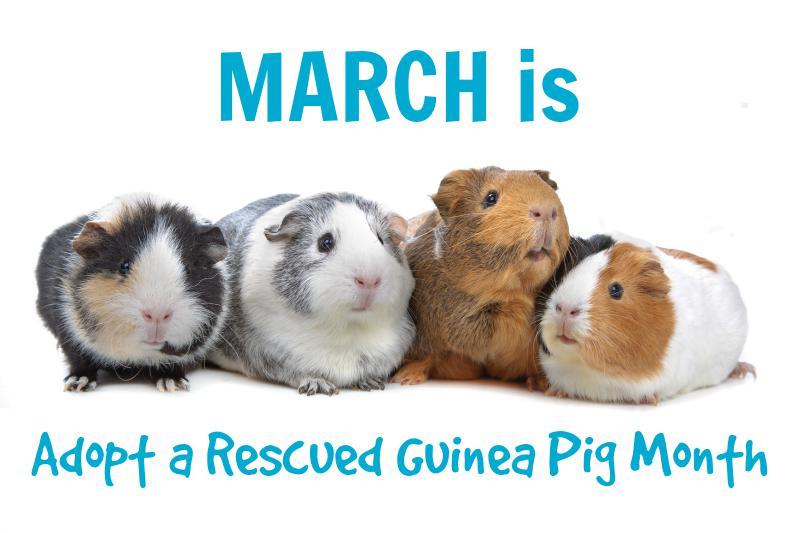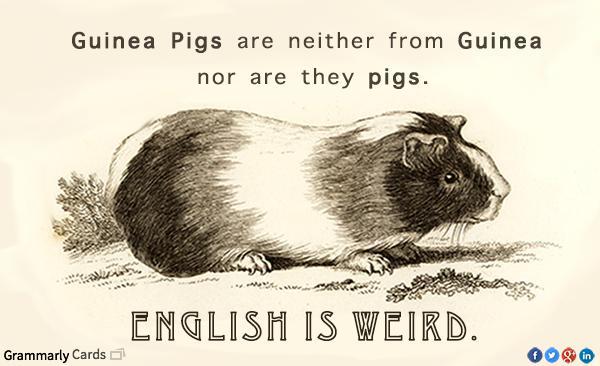The first image is the image on the left, the second image is the image on the right. Considering the images on both sides, is "Four rodents sit in a row in one of the images." valid? Answer yes or no. Yes. The first image is the image on the left, the second image is the image on the right. Given the left and right images, does the statement "An image shows exactly four guinea pigs in a horizontal row." hold true? Answer yes or no. Yes. 